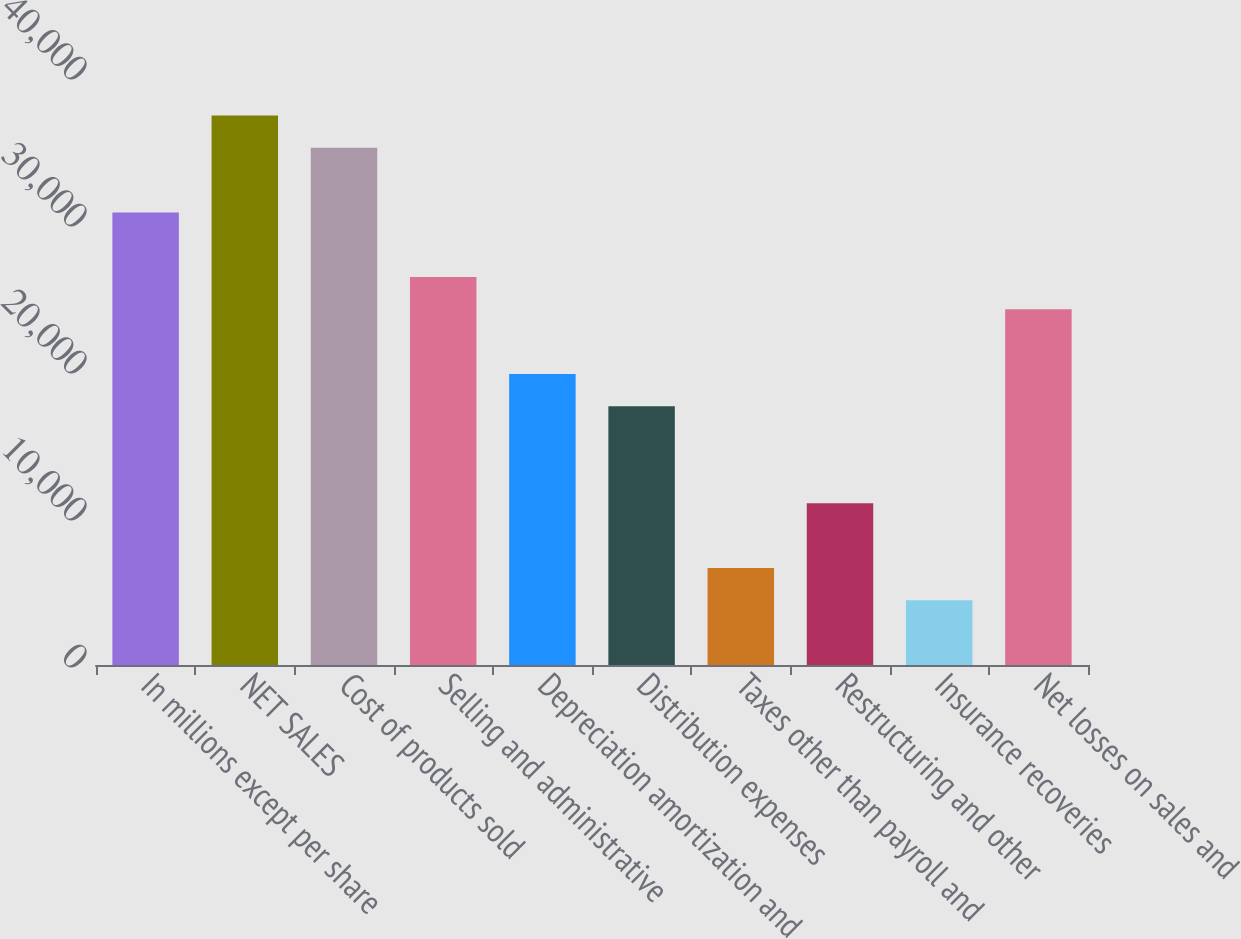Convert chart. <chart><loc_0><loc_0><loc_500><loc_500><bar_chart><fcel>In millions except per share<fcel>NET SALES<fcel>Cost of products sold<fcel>Selling and administrative<fcel>Depreciation amortization and<fcel>Distribution expenses<fcel>Taxes other than payroll and<fcel>Restructuring and other<fcel>Insurance recoveries<fcel>Net losses on sales and<nl><fcel>30790.6<fcel>37387.3<fcel>35188.4<fcel>26392.8<fcel>19796.1<fcel>17597.2<fcel>6602.7<fcel>11000.5<fcel>4403.8<fcel>24193.9<nl></chart> 